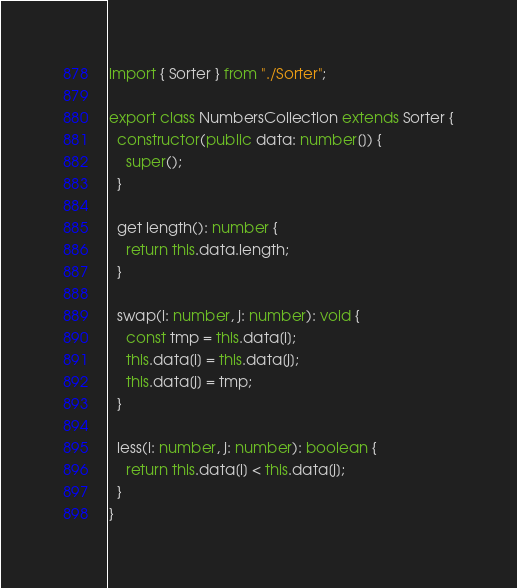<code> <loc_0><loc_0><loc_500><loc_500><_TypeScript_>import { Sorter } from "./Sorter";

export class NumbersCollection extends Sorter {
  constructor(public data: number[]) {
    super();
  }

  get length(): number {
    return this.data.length;
  }

  swap(i: number, j: number): void {
    const tmp = this.data[i];
    this.data[i] = this.data[j];
    this.data[j] = tmp;
  }

  less(i: number, j: number): boolean {
    return this.data[i] < this.data[j];
  }
}
</code> 